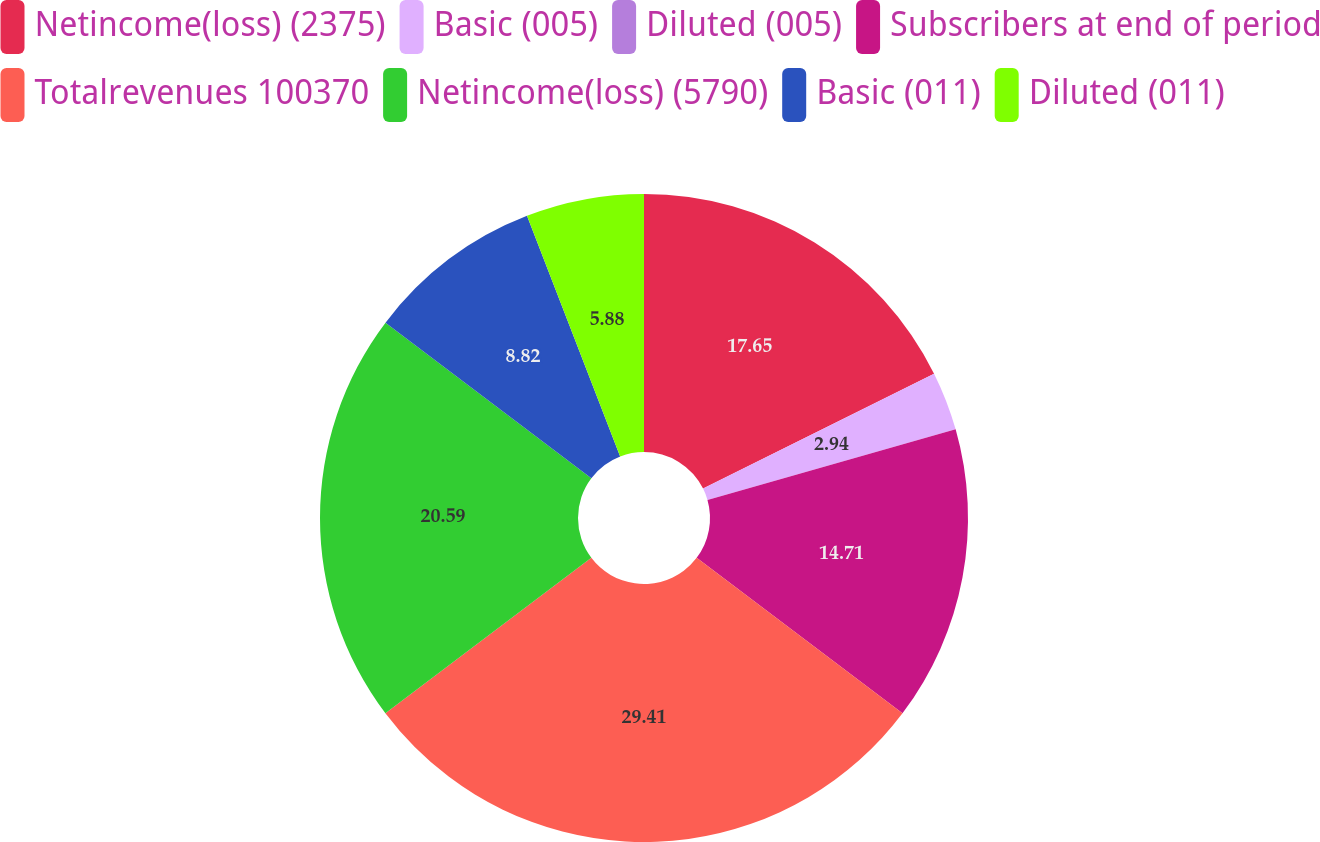<chart> <loc_0><loc_0><loc_500><loc_500><pie_chart><fcel>Netincome(loss) (2375)<fcel>Basic (005)<fcel>Diluted (005)<fcel>Subscribers at end of period<fcel>Totalrevenues 100370<fcel>Netincome(loss) (5790)<fcel>Basic (011)<fcel>Diluted (011)<nl><fcel>17.65%<fcel>2.94%<fcel>0.0%<fcel>14.71%<fcel>29.41%<fcel>20.59%<fcel>8.82%<fcel>5.88%<nl></chart> 